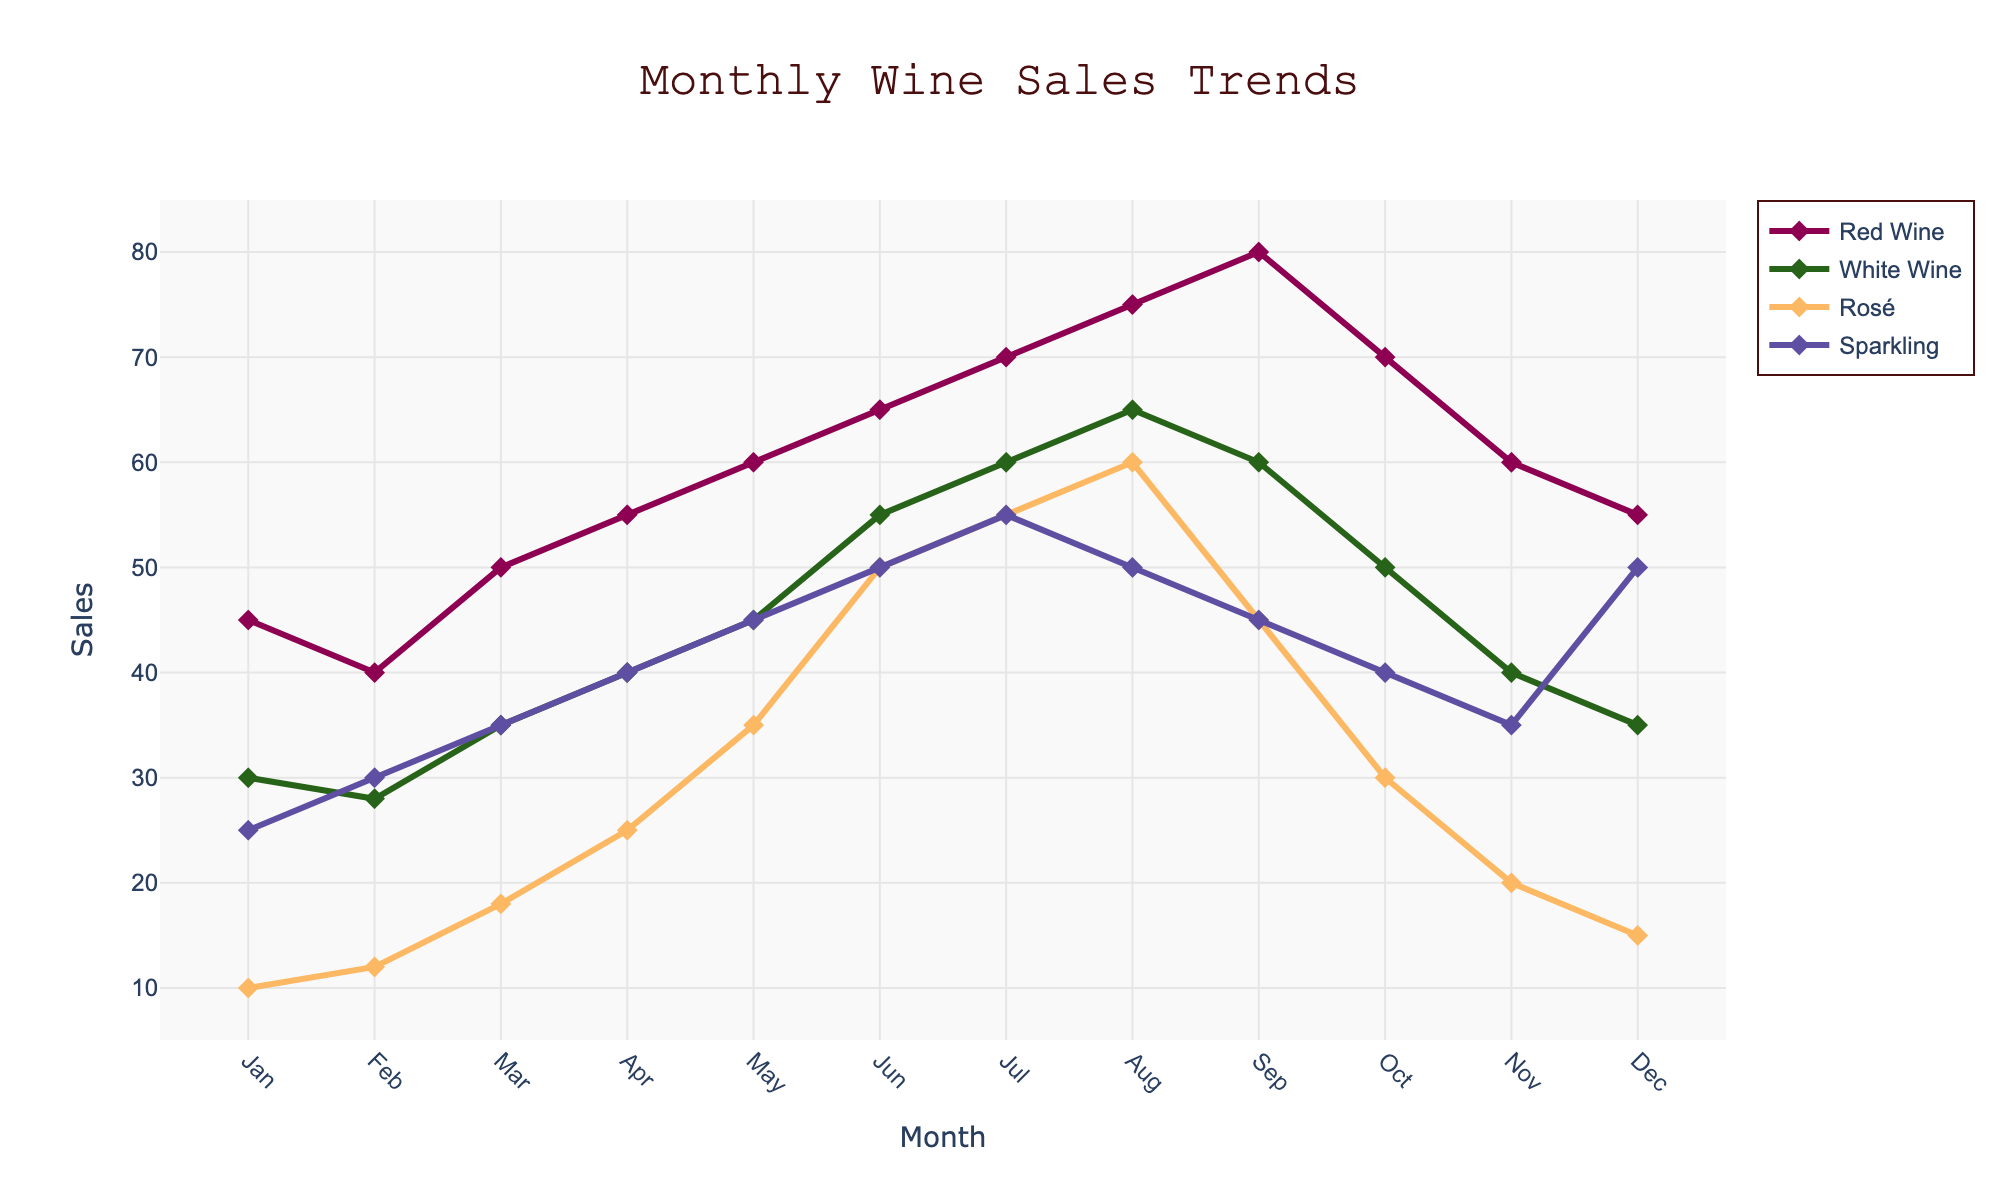What month had the highest sales for Red Wine? By looking at the line corresponding to Red Wine, the peak point occurs in September with a value of 80 bottles.
Answer: September Which type of wine had the most consistent sales throughout the year? Sparkling wine has the least fluctuations, as its line remains relatively steady compared to other wine types.
Answer: Sparkling What is the total sales of Red Wine and White Wine in March? Red Wine sales in March are 50, and White Wine sales are 35. Adding them together gives 50 + 35 = 85 bottles.
Answer: 85 In which month was the difference between Red Wine and Rosé sales the highest? The lines for Red Wine and Rosé are furthest apart in June: Red Wine is at 65, and Rosé is at 50. The difference is 65 - 50 = 15 bottles.
Answer: June Compare the sales of Sparkling wine in December to January. Was there an increase or decrease? In January, Sparkling sales were 25, and in December, they were 50. There is an increase of 50 - 25 = 25 bottles.
Answer: Increase During which month did Rosé see the most significant increase in sales compared to the previous month? The steepest upward slope for Rosé occurs from April (25) to May (35), with an increase of 35 - 25 = 10 bottles.
Answer: May What are the average monthly sales for White Wine over the year? White Wine sales for each month are [30, 28, 35, 40, 45, 55, 60, 65, 60, 50, 40, 35]. Summing these gives 543, and dividing by 12 months gives 543 / 12 ≈ 45.25 bottles.
Answer: 45.25 Which type of wine had the highest sales in July, and how many were sold? The highest point in July belongs to Red Wine, which was 70 bottles.
Answer: Red Wine, 70 In what month did Red Wine sales drop the most compared to the previous month? The largest drop for Red Wine occurs from September (80) to October (70), a decrease of 10 bottles.
Answer: October What is the average month-to-month increase in Sparkling wine sales from January to July? The month-to-month increases are [30-25, 35-30, 40-35, 45-40, 50-45, 55-50] = [5, 5, 5, 5, 5, 5]. The average is (5+5+5+5+5+5)/6 = 5 bottles.
Answer: 5 